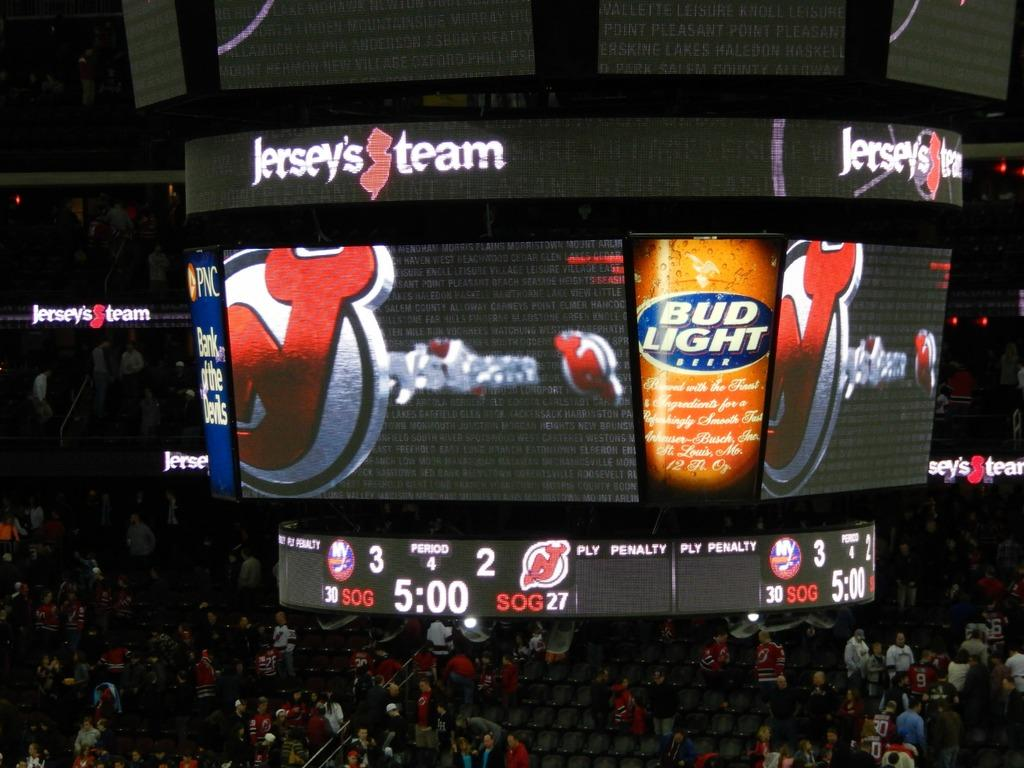Provide a one-sentence caption for the provided image. Budlight is on the big screen of a game with a crowd of people there watching. 